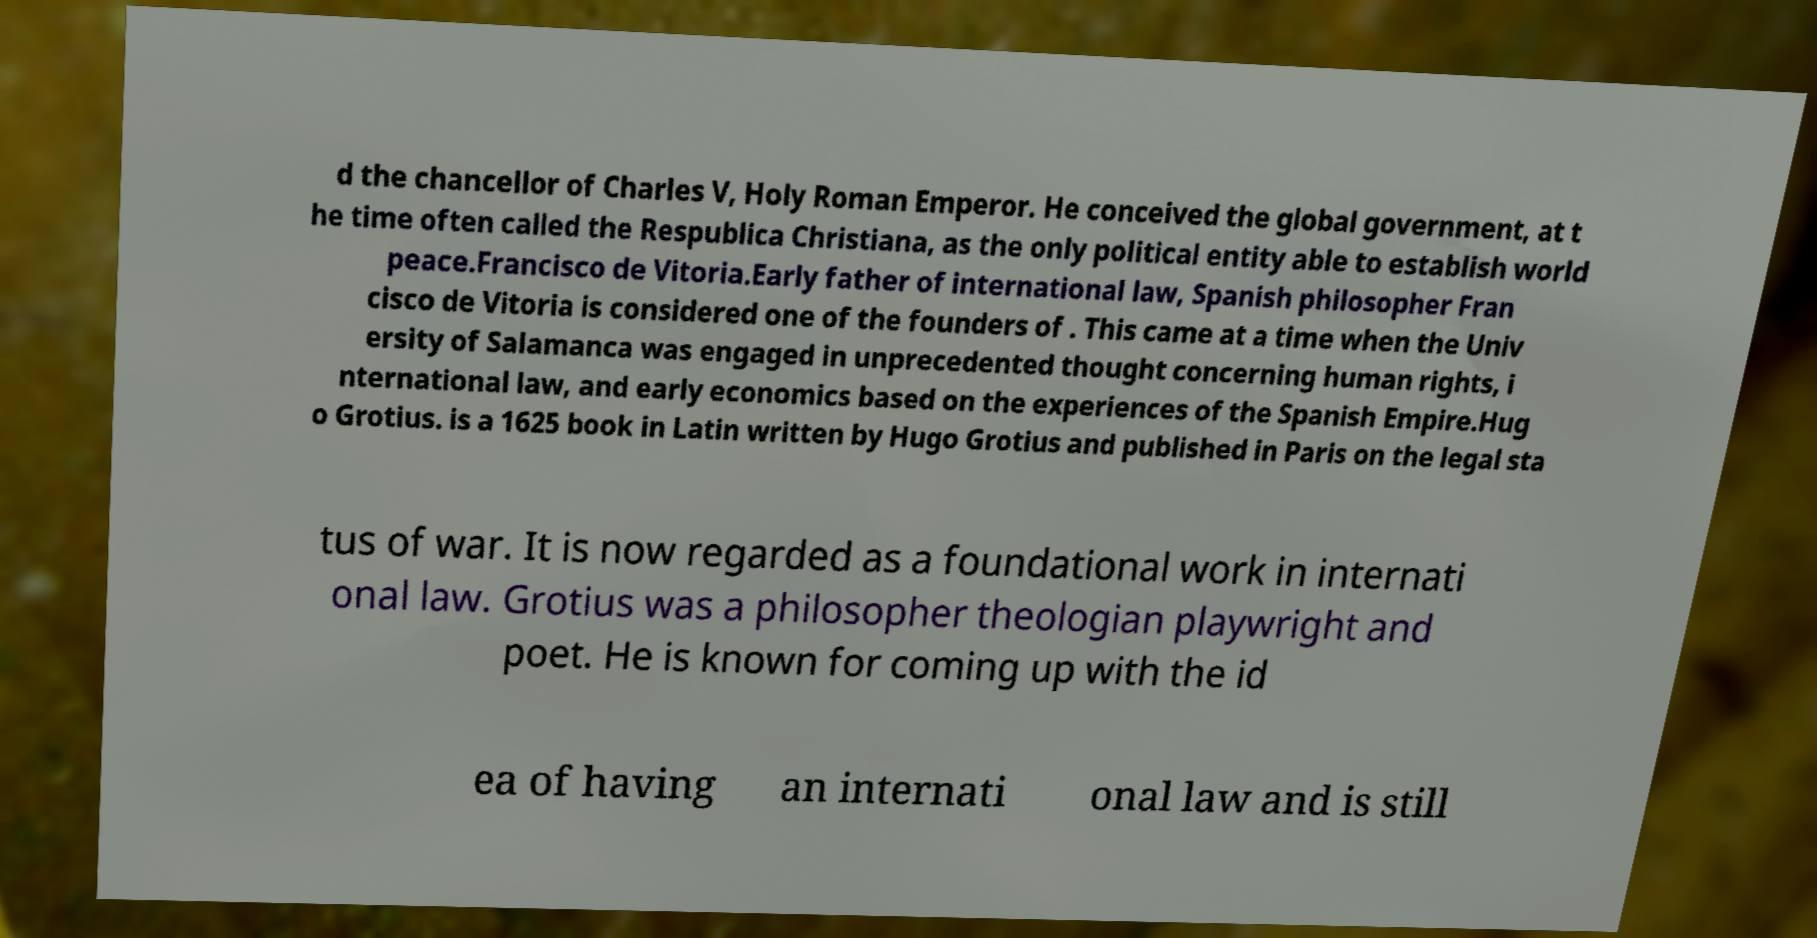Could you extract and type out the text from this image? d the chancellor of Charles V, Holy Roman Emperor. He conceived the global government, at t he time often called the Respublica Christiana, as the only political entity able to establish world peace.Francisco de Vitoria.Early father of international law, Spanish philosopher Fran cisco de Vitoria is considered one of the founders of . This came at a time when the Univ ersity of Salamanca was engaged in unprecedented thought concerning human rights, i nternational law, and early economics based on the experiences of the Spanish Empire.Hug o Grotius. is a 1625 book in Latin written by Hugo Grotius and published in Paris on the legal sta tus of war. It is now regarded as a foundational work in internati onal law. Grotius was a philosopher theologian playwright and poet. He is known for coming up with the id ea of having an internati onal law and is still 